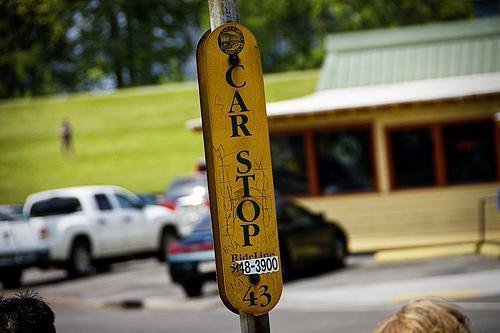How many white cars are there?
Give a very brief answer. 1. 